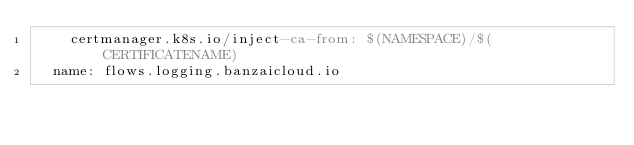<code> <loc_0><loc_0><loc_500><loc_500><_YAML_>    certmanager.k8s.io/inject-ca-from: $(NAMESPACE)/$(CERTIFICATENAME)
  name: flows.logging.banzaicloud.io
</code> 